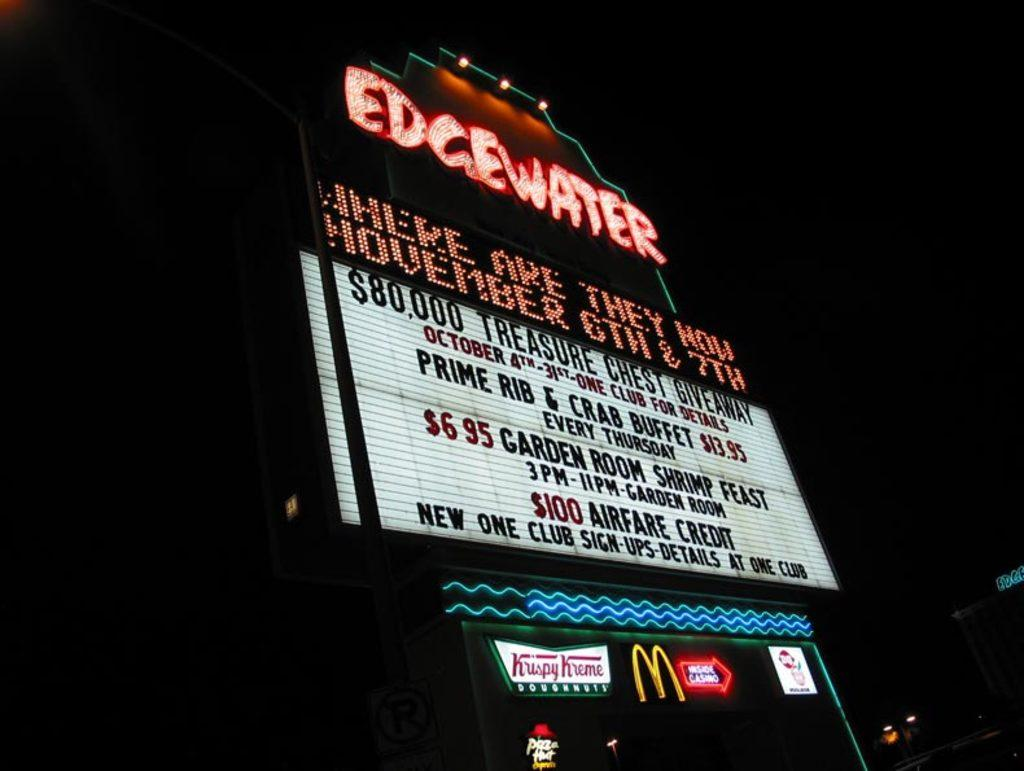What type of structure is present in the image? There is a building in the image. What else can be seen in the image besides the building? There are banners in the image. What is written on the banners? There is some matter written on the banners. How would you describe the lighting in the image? The image is dark. What type of ring is being worn by the person in the image? There is no person present in the image, so it is impossible to determine if someone is wearing a ring. 